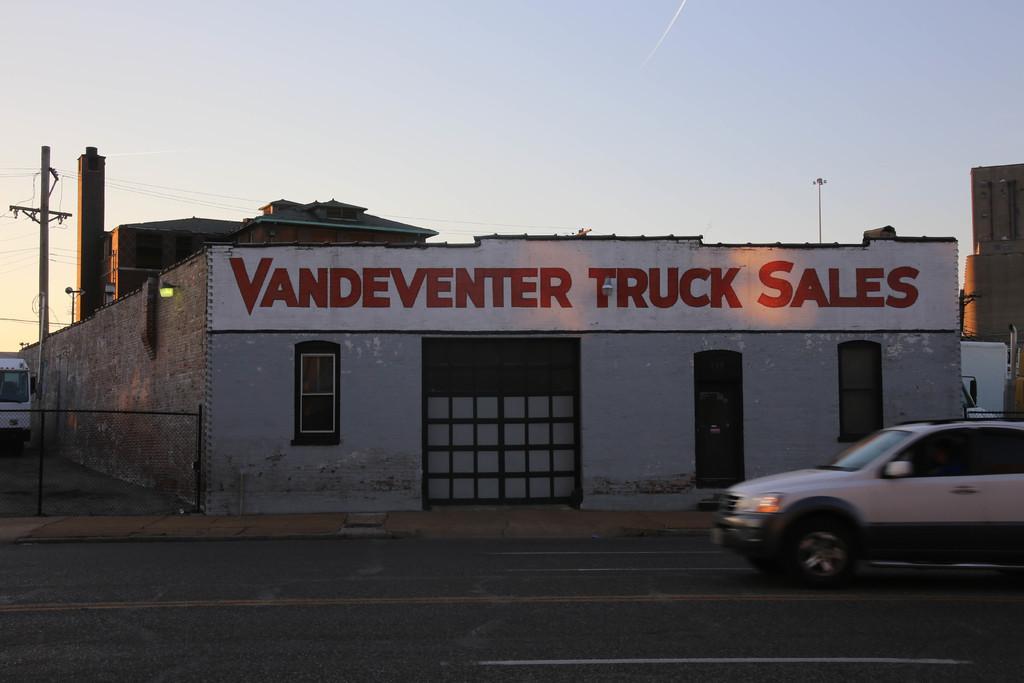Could you give a brief overview of what you see in this image? This image is taken outdoors. At the bottom of the image there is a road. On the right side of the image a car is moving on the road. At the top of the image there is a sky. On the left side of the image a vehicle is parked on the road and there is a pole with wires. In the middle of the image there is a there is a room with a few walls, windows, doors, roof and a board with text on it. 